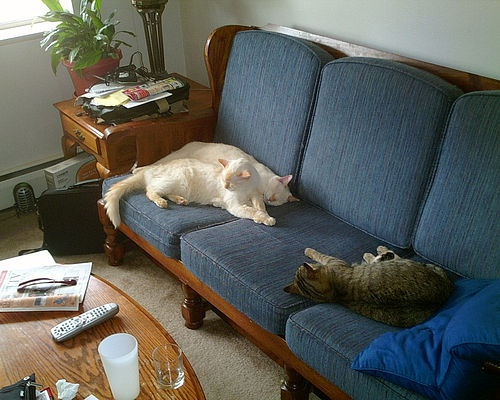Describe the objects in this image and their specific colors. I can see couch in white, gray, black, blue, and darkblue tones, cat in white, black, gray, and darkgreen tones, potted plant in white, darkgreen, gray, ivory, and olive tones, cat in white, beige, gray, darkgray, and tan tones, and handbag in white, black, gray, and maroon tones in this image. 